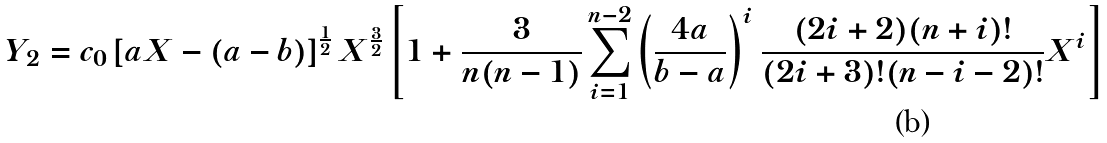Convert formula to latex. <formula><loc_0><loc_0><loc_500><loc_500>Y _ { 2 } = c _ { 0 } \left [ a X - ( a - b ) \right ] ^ { \frac { 1 } { 2 } } X ^ { \frac { 3 } { 2 } } \left [ 1 + \frac { 3 } { n ( n - 1 ) } \sum _ { i = 1 } ^ { n - 2 } \left ( \frac { 4 a } { b - a } \right ) ^ { i } \frac { ( 2 i + 2 ) ( n + i ) ! } { ( 2 i + 3 ) ! ( n - i - 2 ) ! } X ^ { i } \right ]</formula> 